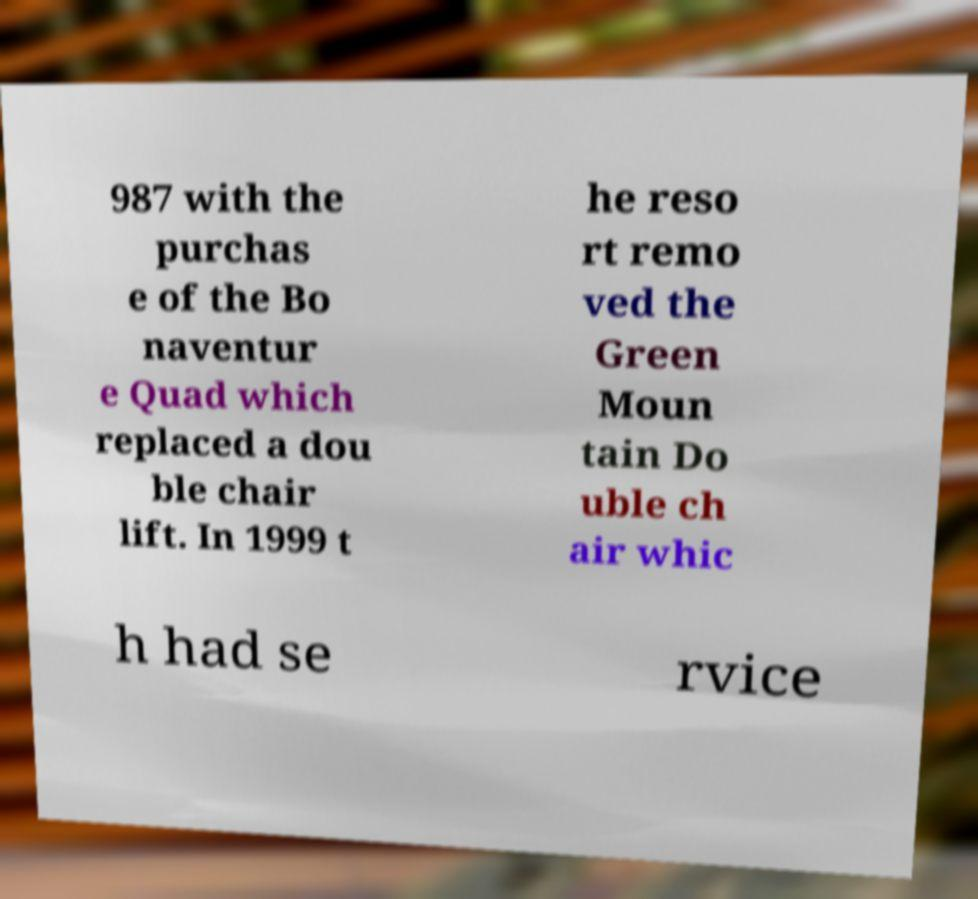Could you assist in decoding the text presented in this image and type it out clearly? 987 with the purchas e of the Bo naventur e Quad which replaced a dou ble chair lift. In 1999 t he reso rt remo ved the Green Moun tain Do uble ch air whic h had se rvice 